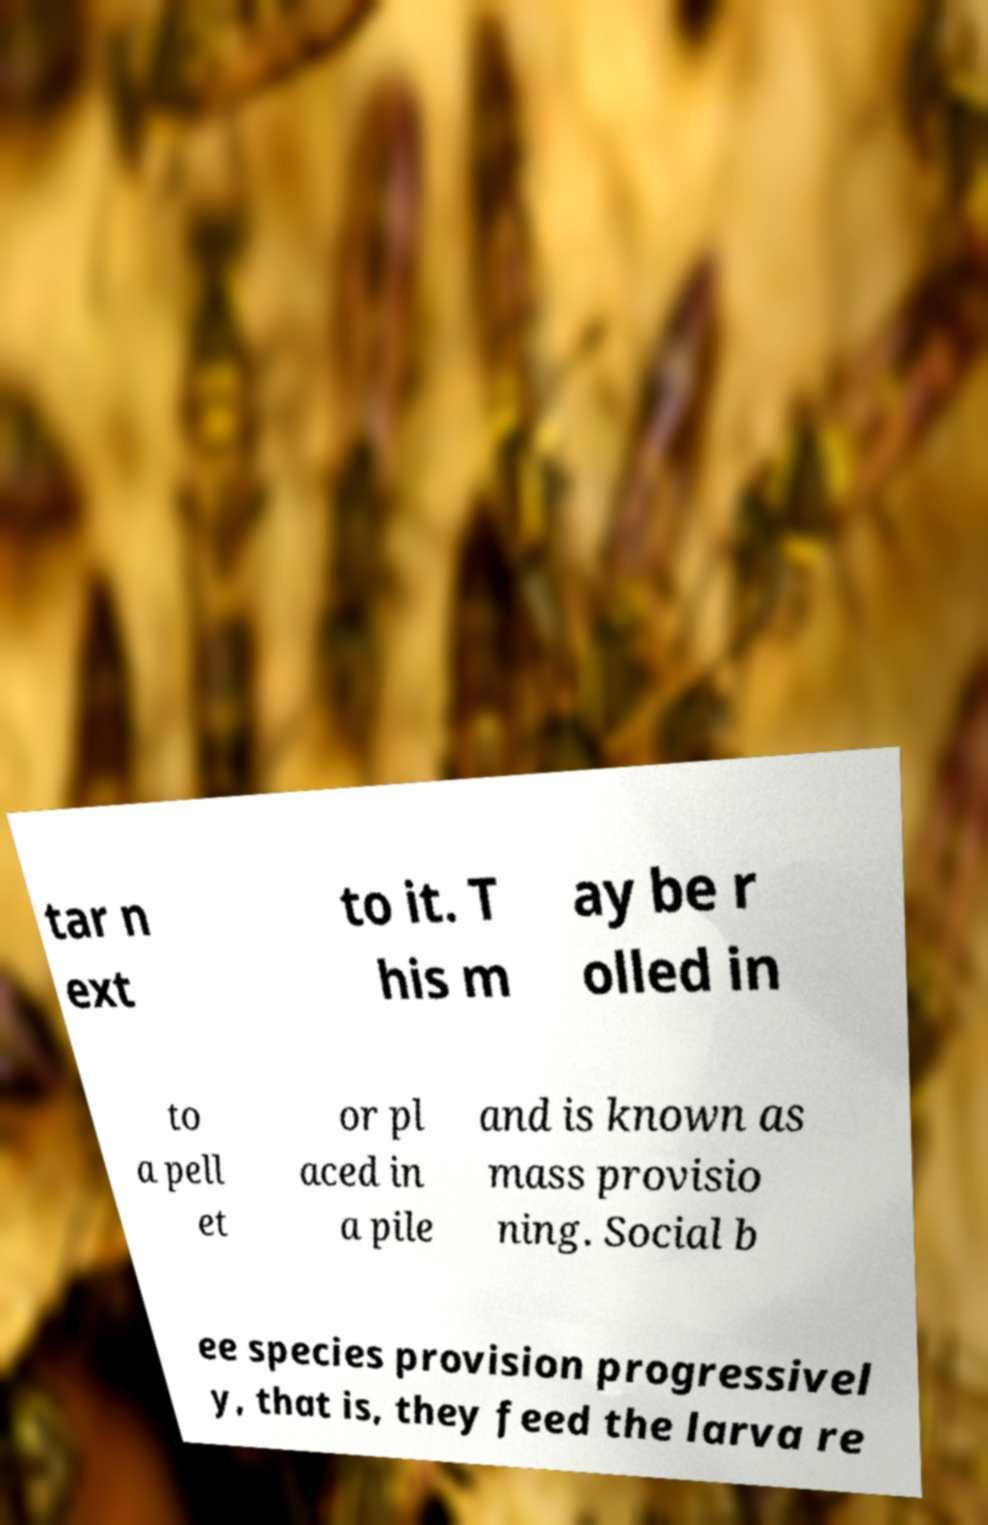Please read and relay the text visible in this image. What does it say? tar n ext to it. T his m ay be r olled in to a pell et or pl aced in a pile and is known as mass provisio ning. Social b ee species provision progressivel y, that is, they feed the larva re 